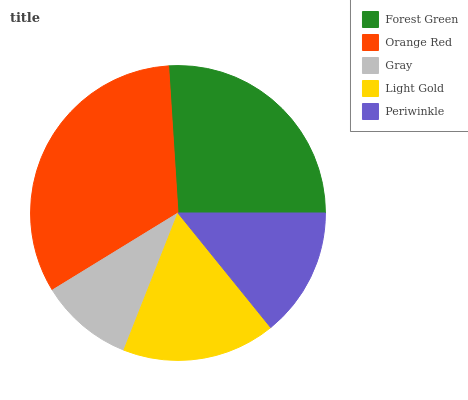Is Gray the minimum?
Answer yes or no. Yes. Is Orange Red the maximum?
Answer yes or no. Yes. Is Orange Red the minimum?
Answer yes or no. No. Is Gray the maximum?
Answer yes or no. No. Is Orange Red greater than Gray?
Answer yes or no. Yes. Is Gray less than Orange Red?
Answer yes or no. Yes. Is Gray greater than Orange Red?
Answer yes or no. No. Is Orange Red less than Gray?
Answer yes or no. No. Is Light Gold the high median?
Answer yes or no. Yes. Is Light Gold the low median?
Answer yes or no. Yes. Is Orange Red the high median?
Answer yes or no. No. Is Periwinkle the low median?
Answer yes or no. No. 